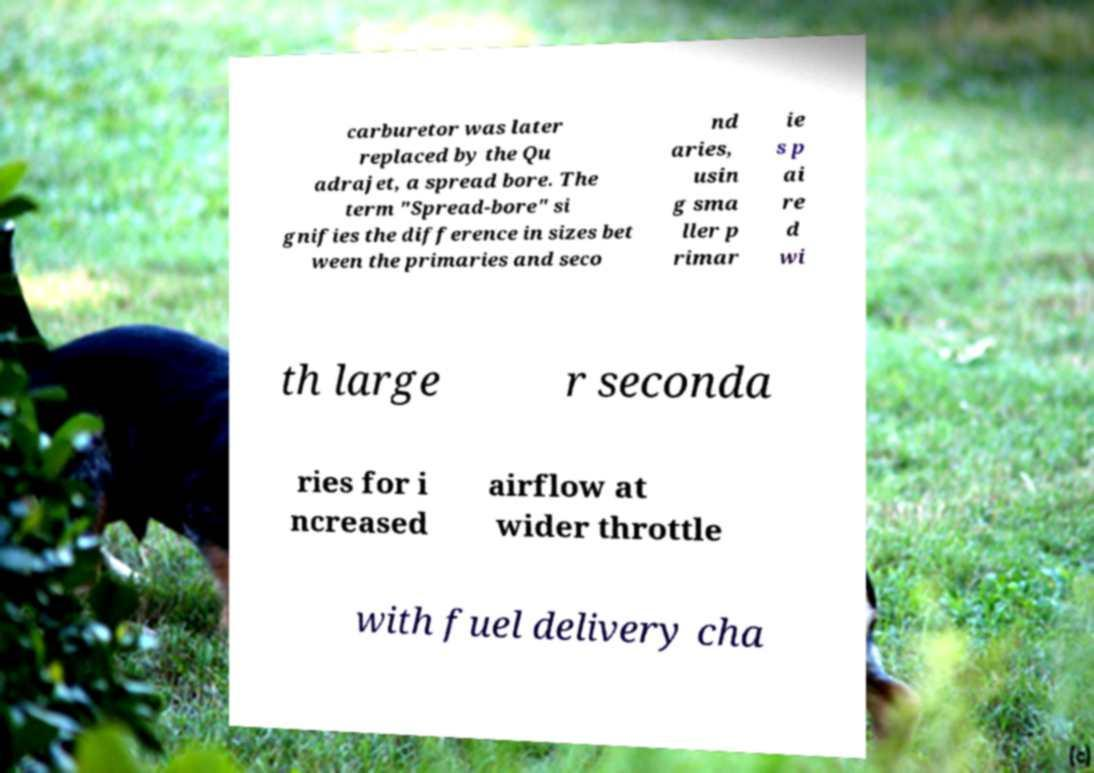I need the written content from this picture converted into text. Can you do that? carburetor was later replaced by the Qu adrajet, a spread bore. The term "Spread-bore" si gnifies the difference in sizes bet ween the primaries and seco nd aries, usin g sma ller p rimar ie s p ai re d wi th large r seconda ries for i ncreased airflow at wider throttle with fuel delivery cha 